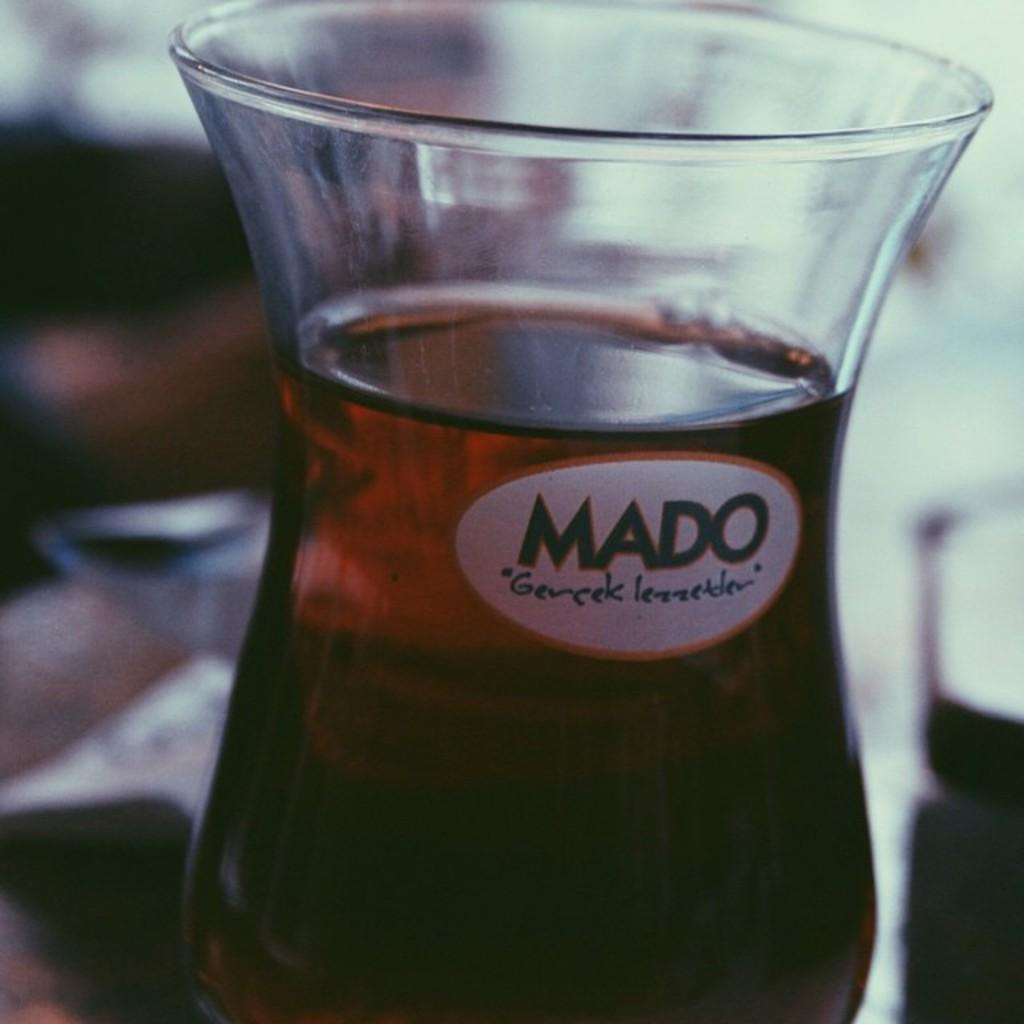<image>
Present a compact description of the photo's key features. A glass of dark liquid which has the word MADO on it. 